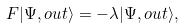<formula> <loc_0><loc_0><loc_500><loc_500>F | \Psi , o u t \rangle = - \lambda | \Psi , o u t \rangle ,</formula> 